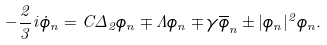Convert formula to latex. <formula><loc_0><loc_0><loc_500><loc_500>- \frac { 2 } { 3 } i \dot { \phi } _ { n } = C \Delta _ { 2 } \phi _ { n } \mp \Lambda \phi _ { n } \mp \gamma \overline { \phi } _ { n } \pm | \phi _ { n } | ^ { 2 } \phi _ { n } .</formula> 